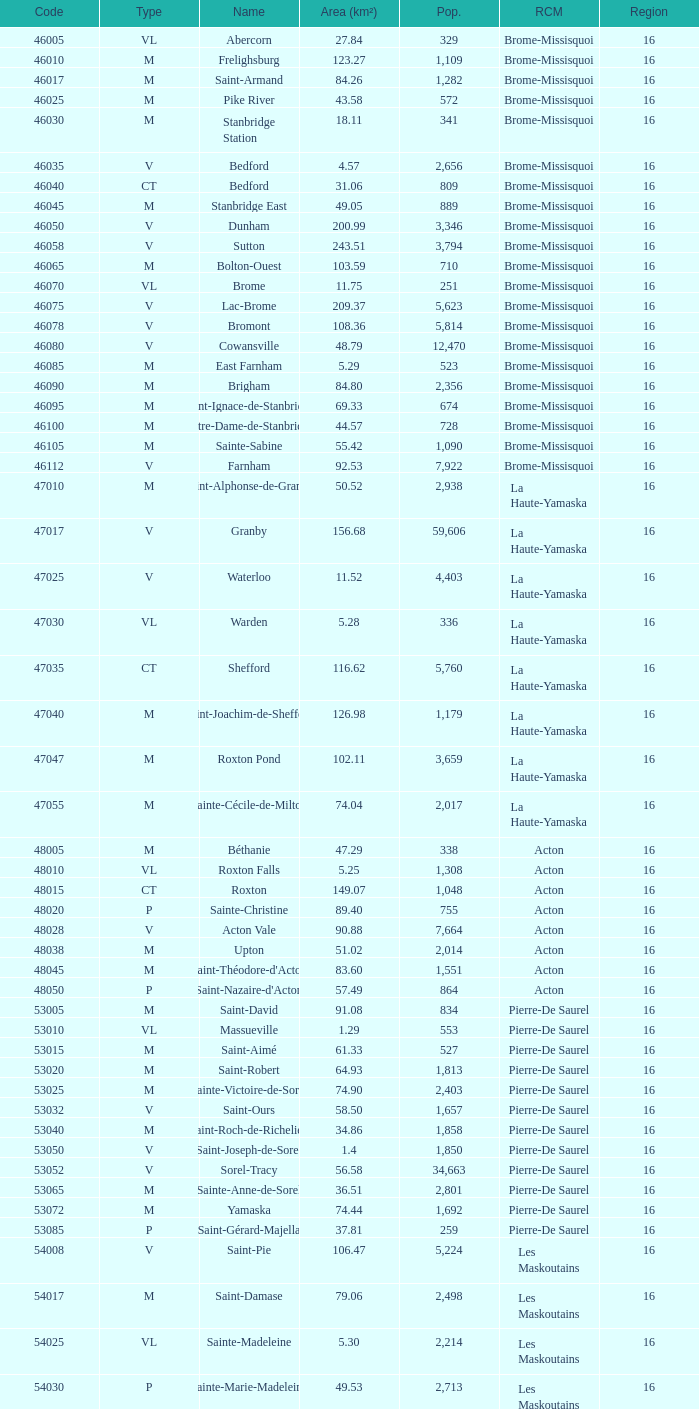Saint-Blaise-Sur-Richelieu is smaller than 68.42 km^2, what is the population of this type M municipality? None. 